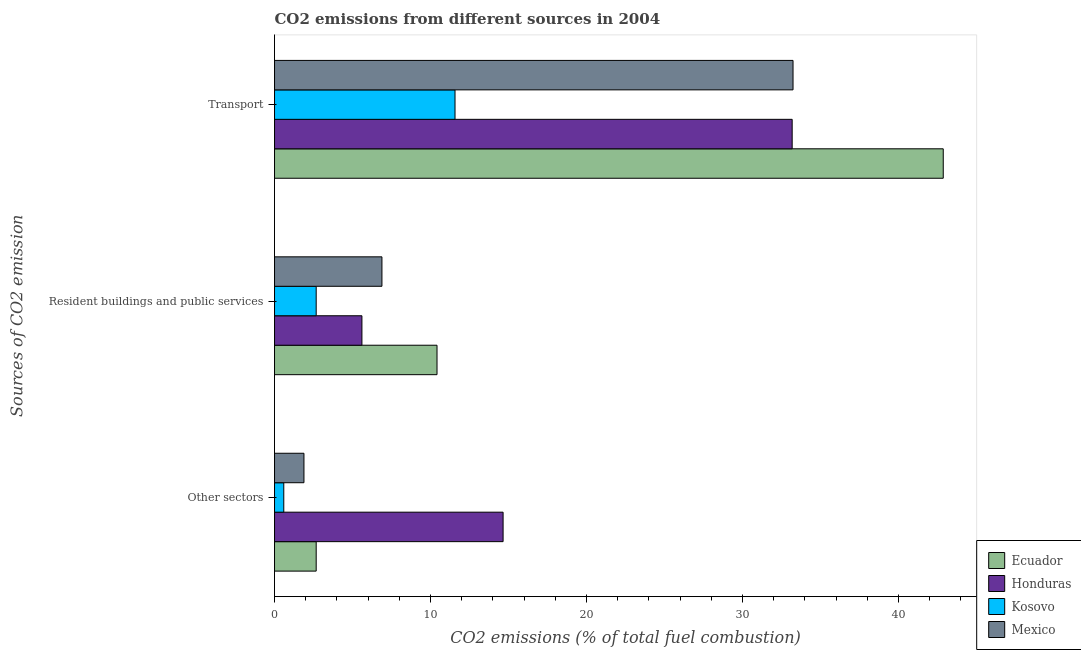How many different coloured bars are there?
Your answer should be very brief. 4. How many groups of bars are there?
Ensure brevity in your answer.  3. Are the number of bars per tick equal to the number of legend labels?
Offer a very short reply. Yes. How many bars are there on the 1st tick from the bottom?
Make the answer very short. 4. What is the label of the 3rd group of bars from the top?
Offer a very short reply. Other sectors. What is the percentage of co2 emissions from other sectors in Kosovo?
Offer a very short reply. 0.59. Across all countries, what is the maximum percentage of co2 emissions from resident buildings and public services?
Provide a succinct answer. 10.42. Across all countries, what is the minimum percentage of co2 emissions from other sectors?
Your answer should be very brief. 0.59. In which country was the percentage of co2 emissions from transport maximum?
Provide a short and direct response. Ecuador. In which country was the percentage of co2 emissions from other sectors minimum?
Provide a succinct answer. Kosovo. What is the total percentage of co2 emissions from resident buildings and public services in the graph?
Give a very brief answer. 25.58. What is the difference between the percentage of co2 emissions from resident buildings and public services in Ecuador and that in Honduras?
Your answer should be compact. 4.82. What is the difference between the percentage of co2 emissions from resident buildings and public services in Mexico and the percentage of co2 emissions from transport in Ecuador?
Offer a terse response. -35.99. What is the average percentage of co2 emissions from other sectors per country?
Your answer should be very brief. 4.95. What is the difference between the percentage of co2 emissions from other sectors and percentage of co2 emissions from resident buildings and public services in Mexico?
Offer a very short reply. -5. What is the ratio of the percentage of co2 emissions from resident buildings and public services in Honduras to that in Kosovo?
Offer a terse response. 2.1. Is the difference between the percentage of co2 emissions from transport in Ecuador and Mexico greater than the difference between the percentage of co2 emissions from resident buildings and public services in Ecuador and Mexico?
Offer a very short reply. Yes. What is the difference between the highest and the second highest percentage of co2 emissions from other sectors?
Make the answer very short. 11.98. What is the difference between the highest and the lowest percentage of co2 emissions from resident buildings and public services?
Provide a short and direct response. 7.75. What does the 3rd bar from the top in Resident buildings and public services represents?
Your answer should be very brief. Honduras. What does the 3rd bar from the bottom in Resident buildings and public services represents?
Ensure brevity in your answer.  Kosovo. Is it the case that in every country, the sum of the percentage of co2 emissions from other sectors and percentage of co2 emissions from resident buildings and public services is greater than the percentage of co2 emissions from transport?
Your response must be concise. No. Are all the bars in the graph horizontal?
Provide a short and direct response. Yes. How many countries are there in the graph?
Give a very brief answer. 4. Are the values on the major ticks of X-axis written in scientific E-notation?
Provide a succinct answer. No. How are the legend labels stacked?
Your response must be concise. Vertical. What is the title of the graph?
Offer a very short reply. CO2 emissions from different sources in 2004. What is the label or title of the X-axis?
Your answer should be compact. CO2 emissions (% of total fuel combustion). What is the label or title of the Y-axis?
Give a very brief answer. Sources of CO2 emission. What is the CO2 emissions (% of total fuel combustion) in Ecuador in Other sectors?
Give a very brief answer. 2.67. What is the CO2 emissions (% of total fuel combustion) in Honduras in Other sectors?
Provide a short and direct response. 14.66. What is the CO2 emissions (% of total fuel combustion) of Kosovo in Other sectors?
Offer a very short reply. 0.59. What is the CO2 emissions (% of total fuel combustion) in Mexico in Other sectors?
Provide a short and direct response. 1.89. What is the CO2 emissions (% of total fuel combustion) in Ecuador in Resident buildings and public services?
Your answer should be very brief. 10.42. What is the CO2 emissions (% of total fuel combustion) of Honduras in Resident buildings and public services?
Ensure brevity in your answer.  5.6. What is the CO2 emissions (% of total fuel combustion) of Kosovo in Resident buildings and public services?
Your answer should be very brief. 2.67. What is the CO2 emissions (% of total fuel combustion) in Mexico in Resident buildings and public services?
Offer a terse response. 6.89. What is the CO2 emissions (% of total fuel combustion) of Ecuador in Transport?
Offer a very short reply. 42.88. What is the CO2 emissions (% of total fuel combustion) in Honduras in Transport?
Make the answer very short. 33.19. What is the CO2 emissions (% of total fuel combustion) in Kosovo in Transport?
Your answer should be very brief. 11.57. What is the CO2 emissions (% of total fuel combustion) of Mexico in Transport?
Ensure brevity in your answer.  33.24. Across all Sources of CO2 emission, what is the maximum CO2 emissions (% of total fuel combustion) in Ecuador?
Give a very brief answer. 42.88. Across all Sources of CO2 emission, what is the maximum CO2 emissions (% of total fuel combustion) of Honduras?
Your answer should be compact. 33.19. Across all Sources of CO2 emission, what is the maximum CO2 emissions (% of total fuel combustion) in Kosovo?
Offer a terse response. 11.57. Across all Sources of CO2 emission, what is the maximum CO2 emissions (% of total fuel combustion) of Mexico?
Your answer should be very brief. 33.24. Across all Sources of CO2 emission, what is the minimum CO2 emissions (% of total fuel combustion) in Ecuador?
Offer a terse response. 2.67. Across all Sources of CO2 emission, what is the minimum CO2 emissions (% of total fuel combustion) of Honduras?
Your answer should be very brief. 5.6. Across all Sources of CO2 emission, what is the minimum CO2 emissions (% of total fuel combustion) of Kosovo?
Give a very brief answer. 0.59. Across all Sources of CO2 emission, what is the minimum CO2 emissions (% of total fuel combustion) of Mexico?
Your answer should be very brief. 1.89. What is the total CO2 emissions (% of total fuel combustion) in Ecuador in the graph?
Provide a succinct answer. 55.97. What is the total CO2 emissions (% of total fuel combustion) in Honduras in the graph?
Keep it short and to the point. 53.45. What is the total CO2 emissions (% of total fuel combustion) of Kosovo in the graph?
Provide a short and direct response. 14.84. What is the total CO2 emissions (% of total fuel combustion) in Mexico in the graph?
Offer a very short reply. 42.02. What is the difference between the CO2 emissions (% of total fuel combustion) of Ecuador in Other sectors and that in Resident buildings and public services?
Ensure brevity in your answer.  -7.75. What is the difference between the CO2 emissions (% of total fuel combustion) of Honduras in Other sectors and that in Resident buildings and public services?
Make the answer very short. 9.05. What is the difference between the CO2 emissions (% of total fuel combustion) in Kosovo in Other sectors and that in Resident buildings and public services?
Offer a very short reply. -2.08. What is the difference between the CO2 emissions (% of total fuel combustion) of Mexico in Other sectors and that in Resident buildings and public services?
Provide a short and direct response. -5. What is the difference between the CO2 emissions (% of total fuel combustion) of Ecuador in Other sectors and that in Transport?
Give a very brief answer. -40.2. What is the difference between the CO2 emissions (% of total fuel combustion) in Honduras in Other sectors and that in Transport?
Give a very brief answer. -18.53. What is the difference between the CO2 emissions (% of total fuel combustion) in Kosovo in Other sectors and that in Transport?
Your answer should be compact. -10.98. What is the difference between the CO2 emissions (% of total fuel combustion) of Mexico in Other sectors and that in Transport?
Make the answer very short. -31.36. What is the difference between the CO2 emissions (% of total fuel combustion) of Ecuador in Resident buildings and public services and that in Transport?
Offer a very short reply. -32.46. What is the difference between the CO2 emissions (% of total fuel combustion) of Honduras in Resident buildings and public services and that in Transport?
Your answer should be compact. -27.59. What is the difference between the CO2 emissions (% of total fuel combustion) of Kosovo in Resident buildings and public services and that in Transport?
Your answer should be very brief. -8.9. What is the difference between the CO2 emissions (% of total fuel combustion) of Mexico in Resident buildings and public services and that in Transport?
Give a very brief answer. -26.36. What is the difference between the CO2 emissions (% of total fuel combustion) in Ecuador in Other sectors and the CO2 emissions (% of total fuel combustion) in Honduras in Resident buildings and public services?
Make the answer very short. -2.93. What is the difference between the CO2 emissions (% of total fuel combustion) of Ecuador in Other sectors and the CO2 emissions (% of total fuel combustion) of Kosovo in Resident buildings and public services?
Ensure brevity in your answer.  0. What is the difference between the CO2 emissions (% of total fuel combustion) of Ecuador in Other sectors and the CO2 emissions (% of total fuel combustion) of Mexico in Resident buildings and public services?
Your answer should be very brief. -4.21. What is the difference between the CO2 emissions (% of total fuel combustion) in Honduras in Other sectors and the CO2 emissions (% of total fuel combustion) in Kosovo in Resident buildings and public services?
Offer a terse response. 11.98. What is the difference between the CO2 emissions (% of total fuel combustion) of Honduras in Other sectors and the CO2 emissions (% of total fuel combustion) of Mexico in Resident buildings and public services?
Make the answer very short. 7.77. What is the difference between the CO2 emissions (% of total fuel combustion) in Kosovo in Other sectors and the CO2 emissions (% of total fuel combustion) in Mexico in Resident buildings and public services?
Your answer should be compact. -6.29. What is the difference between the CO2 emissions (% of total fuel combustion) in Ecuador in Other sectors and the CO2 emissions (% of total fuel combustion) in Honduras in Transport?
Make the answer very short. -30.52. What is the difference between the CO2 emissions (% of total fuel combustion) of Ecuador in Other sectors and the CO2 emissions (% of total fuel combustion) of Kosovo in Transport?
Your answer should be very brief. -8.9. What is the difference between the CO2 emissions (% of total fuel combustion) of Ecuador in Other sectors and the CO2 emissions (% of total fuel combustion) of Mexico in Transport?
Your response must be concise. -30.57. What is the difference between the CO2 emissions (% of total fuel combustion) in Honduras in Other sectors and the CO2 emissions (% of total fuel combustion) in Kosovo in Transport?
Provide a short and direct response. 3.08. What is the difference between the CO2 emissions (% of total fuel combustion) in Honduras in Other sectors and the CO2 emissions (% of total fuel combustion) in Mexico in Transport?
Offer a terse response. -18.59. What is the difference between the CO2 emissions (% of total fuel combustion) of Kosovo in Other sectors and the CO2 emissions (% of total fuel combustion) of Mexico in Transport?
Your answer should be very brief. -32.65. What is the difference between the CO2 emissions (% of total fuel combustion) of Ecuador in Resident buildings and public services and the CO2 emissions (% of total fuel combustion) of Honduras in Transport?
Provide a short and direct response. -22.77. What is the difference between the CO2 emissions (% of total fuel combustion) of Ecuador in Resident buildings and public services and the CO2 emissions (% of total fuel combustion) of Kosovo in Transport?
Ensure brevity in your answer.  -1.15. What is the difference between the CO2 emissions (% of total fuel combustion) in Ecuador in Resident buildings and public services and the CO2 emissions (% of total fuel combustion) in Mexico in Transport?
Your answer should be very brief. -22.83. What is the difference between the CO2 emissions (% of total fuel combustion) of Honduras in Resident buildings and public services and the CO2 emissions (% of total fuel combustion) of Kosovo in Transport?
Provide a short and direct response. -5.97. What is the difference between the CO2 emissions (% of total fuel combustion) of Honduras in Resident buildings and public services and the CO2 emissions (% of total fuel combustion) of Mexico in Transport?
Keep it short and to the point. -27.64. What is the difference between the CO2 emissions (% of total fuel combustion) in Kosovo in Resident buildings and public services and the CO2 emissions (% of total fuel combustion) in Mexico in Transport?
Give a very brief answer. -30.57. What is the average CO2 emissions (% of total fuel combustion) in Ecuador per Sources of CO2 emission?
Offer a very short reply. 18.66. What is the average CO2 emissions (% of total fuel combustion) in Honduras per Sources of CO2 emission?
Make the answer very short. 17.82. What is the average CO2 emissions (% of total fuel combustion) in Kosovo per Sources of CO2 emission?
Provide a short and direct response. 4.95. What is the average CO2 emissions (% of total fuel combustion) of Mexico per Sources of CO2 emission?
Give a very brief answer. 14.01. What is the difference between the CO2 emissions (% of total fuel combustion) of Ecuador and CO2 emissions (% of total fuel combustion) of Honduras in Other sectors?
Give a very brief answer. -11.98. What is the difference between the CO2 emissions (% of total fuel combustion) of Ecuador and CO2 emissions (% of total fuel combustion) of Kosovo in Other sectors?
Your response must be concise. 2.08. What is the difference between the CO2 emissions (% of total fuel combustion) in Ecuador and CO2 emissions (% of total fuel combustion) in Mexico in Other sectors?
Give a very brief answer. 0.78. What is the difference between the CO2 emissions (% of total fuel combustion) in Honduras and CO2 emissions (% of total fuel combustion) in Kosovo in Other sectors?
Offer a very short reply. 14.06. What is the difference between the CO2 emissions (% of total fuel combustion) of Honduras and CO2 emissions (% of total fuel combustion) of Mexico in Other sectors?
Offer a very short reply. 12.77. What is the difference between the CO2 emissions (% of total fuel combustion) of Kosovo and CO2 emissions (% of total fuel combustion) of Mexico in Other sectors?
Your response must be concise. -1.29. What is the difference between the CO2 emissions (% of total fuel combustion) of Ecuador and CO2 emissions (% of total fuel combustion) of Honduras in Resident buildings and public services?
Keep it short and to the point. 4.82. What is the difference between the CO2 emissions (% of total fuel combustion) in Ecuador and CO2 emissions (% of total fuel combustion) in Kosovo in Resident buildings and public services?
Give a very brief answer. 7.75. What is the difference between the CO2 emissions (% of total fuel combustion) of Ecuador and CO2 emissions (% of total fuel combustion) of Mexico in Resident buildings and public services?
Provide a short and direct response. 3.53. What is the difference between the CO2 emissions (% of total fuel combustion) in Honduras and CO2 emissions (% of total fuel combustion) in Kosovo in Resident buildings and public services?
Make the answer very short. 2.93. What is the difference between the CO2 emissions (% of total fuel combustion) of Honduras and CO2 emissions (% of total fuel combustion) of Mexico in Resident buildings and public services?
Your answer should be very brief. -1.28. What is the difference between the CO2 emissions (% of total fuel combustion) in Kosovo and CO2 emissions (% of total fuel combustion) in Mexico in Resident buildings and public services?
Your response must be concise. -4.22. What is the difference between the CO2 emissions (% of total fuel combustion) in Ecuador and CO2 emissions (% of total fuel combustion) in Honduras in Transport?
Keep it short and to the point. 9.69. What is the difference between the CO2 emissions (% of total fuel combustion) in Ecuador and CO2 emissions (% of total fuel combustion) in Kosovo in Transport?
Your answer should be very brief. 31.3. What is the difference between the CO2 emissions (% of total fuel combustion) of Ecuador and CO2 emissions (% of total fuel combustion) of Mexico in Transport?
Ensure brevity in your answer.  9.63. What is the difference between the CO2 emissions (% of total fuel combustion) of Honduras and CO2 emissions (% of total fuel combustion) of Kosovo in Transport?
Your answer should be compact. 21.62. What is the difference between the CO2 emissions (% of total fuel combustion) of Honduras and CO2 emissions (% of total fuel combustion) of Mexico in Transport?
Your answer should be very brief. -0.06. What is the difference between the CO2 emissions (% of total fuel combustion) of Kosovo and CO2 emissions (% of total fuel combustion) of Mexico in Transport?
Your answer should be very brief. -21.67. What is the ratio of the CO2 emissions (% of total fuel combustion) of Ecuador in Other sectors to that in Resident buildings and public services?
Offer a terse response. 0.26. What is the ratio of the CO2 emissions (% of total fuel combustion) of Honduras in Other sectors to that in Resident buildings and public services?
Provide a short and direct response. 2.62. What is the ratio of the CO2 emissions (% of total fuel combustion) in Kosovo in Other sectors to that in Resident buildings and public services?
Offer a terse response. 0.22. What is the ratio of the CO2 emissions (% of total fuel combustion) in Mexico in Other sectors to that in Resident buildings and public services?
Offer a very short reply. 0.27. What is the ratio of the CO2 emissions (% of total fuel combustion) in Ecuador in Other sectors to that in Transport?
Your response must be concise. 0.06. What is the ratio of the CO2 emissions (% of total fuel combustion) of Honduras in Other sectors to that in Transport?
Provide a short and direct response. 0.44. What is the ratio of the CO2 emissions (% of total fuel combustion) of Kosovo in Other sectors to that in Transport?
Offer a terse response. 0.05. What is the ratio of the CO2 emissions (% of total fuel combustion) in Mexico in Other sectors to that in Transport?
Keep it short and to the point. 0.06. What is the ratio of the CO2 emissions (% of total fuel combustion) in Ecuador in Resident buildings and public services to that in Transport?
Keep it short and to the point. 0.24. What is the ratio of the CO2 emissions (% of total fuel combustion) of Honduras in Resident buildings and public services to that in Transport?
Give a very brief answer. 0.17. What is the ratio of the CO2 emissions (% of total fuel combustion) of Kosovo in Resident buildings and public services to that in Transport?
Offer a very short reply. 0.23. What is the ratio of the CO2 emissions (% of total fuel combustion) of Mexico in Resident buildings and public services to that in Transport?
Keep it short and to the point. 0.21. What is the difference between the highest and the second highest CO2 emissions (% of total fuel combustion) of Ecuador?
Your response must be concise. 32.46. What is the difference between the highest and the second highest CO2 emissions (% of total fuel combustion) of Honduras?
Make the answer very short. 18.53. What is the difference between the highest and the second highest CO2 emissions (% of total fuel combustion) of Kosovo?
Make the answer very short. 8.9. What is the difference between the highest and the second highest CO2 emissions (% of total fuel combustion) in Mexico?
Offer a very short reply. 26.36. What is the difference between the highest and the lowest CO2 emissions (% of total fuel combustion) in Ecuador?
Your response must be concise. 40.2. What is the difference between the highest and the lowest CO2 emissions (% of total fuel combustion) in Honduras?
Offer a very short reply. 27.59. What is the difference between the highest and the lowest CO2 emissions (% of total fuel combustion) in Kosovo?
Ensure brevity in your answer.  10.98. What is the difference between the highest and the lowest CO2 emissions (% of total fuel combustion) of Mexico?
Offer a terse response. 31.36. 